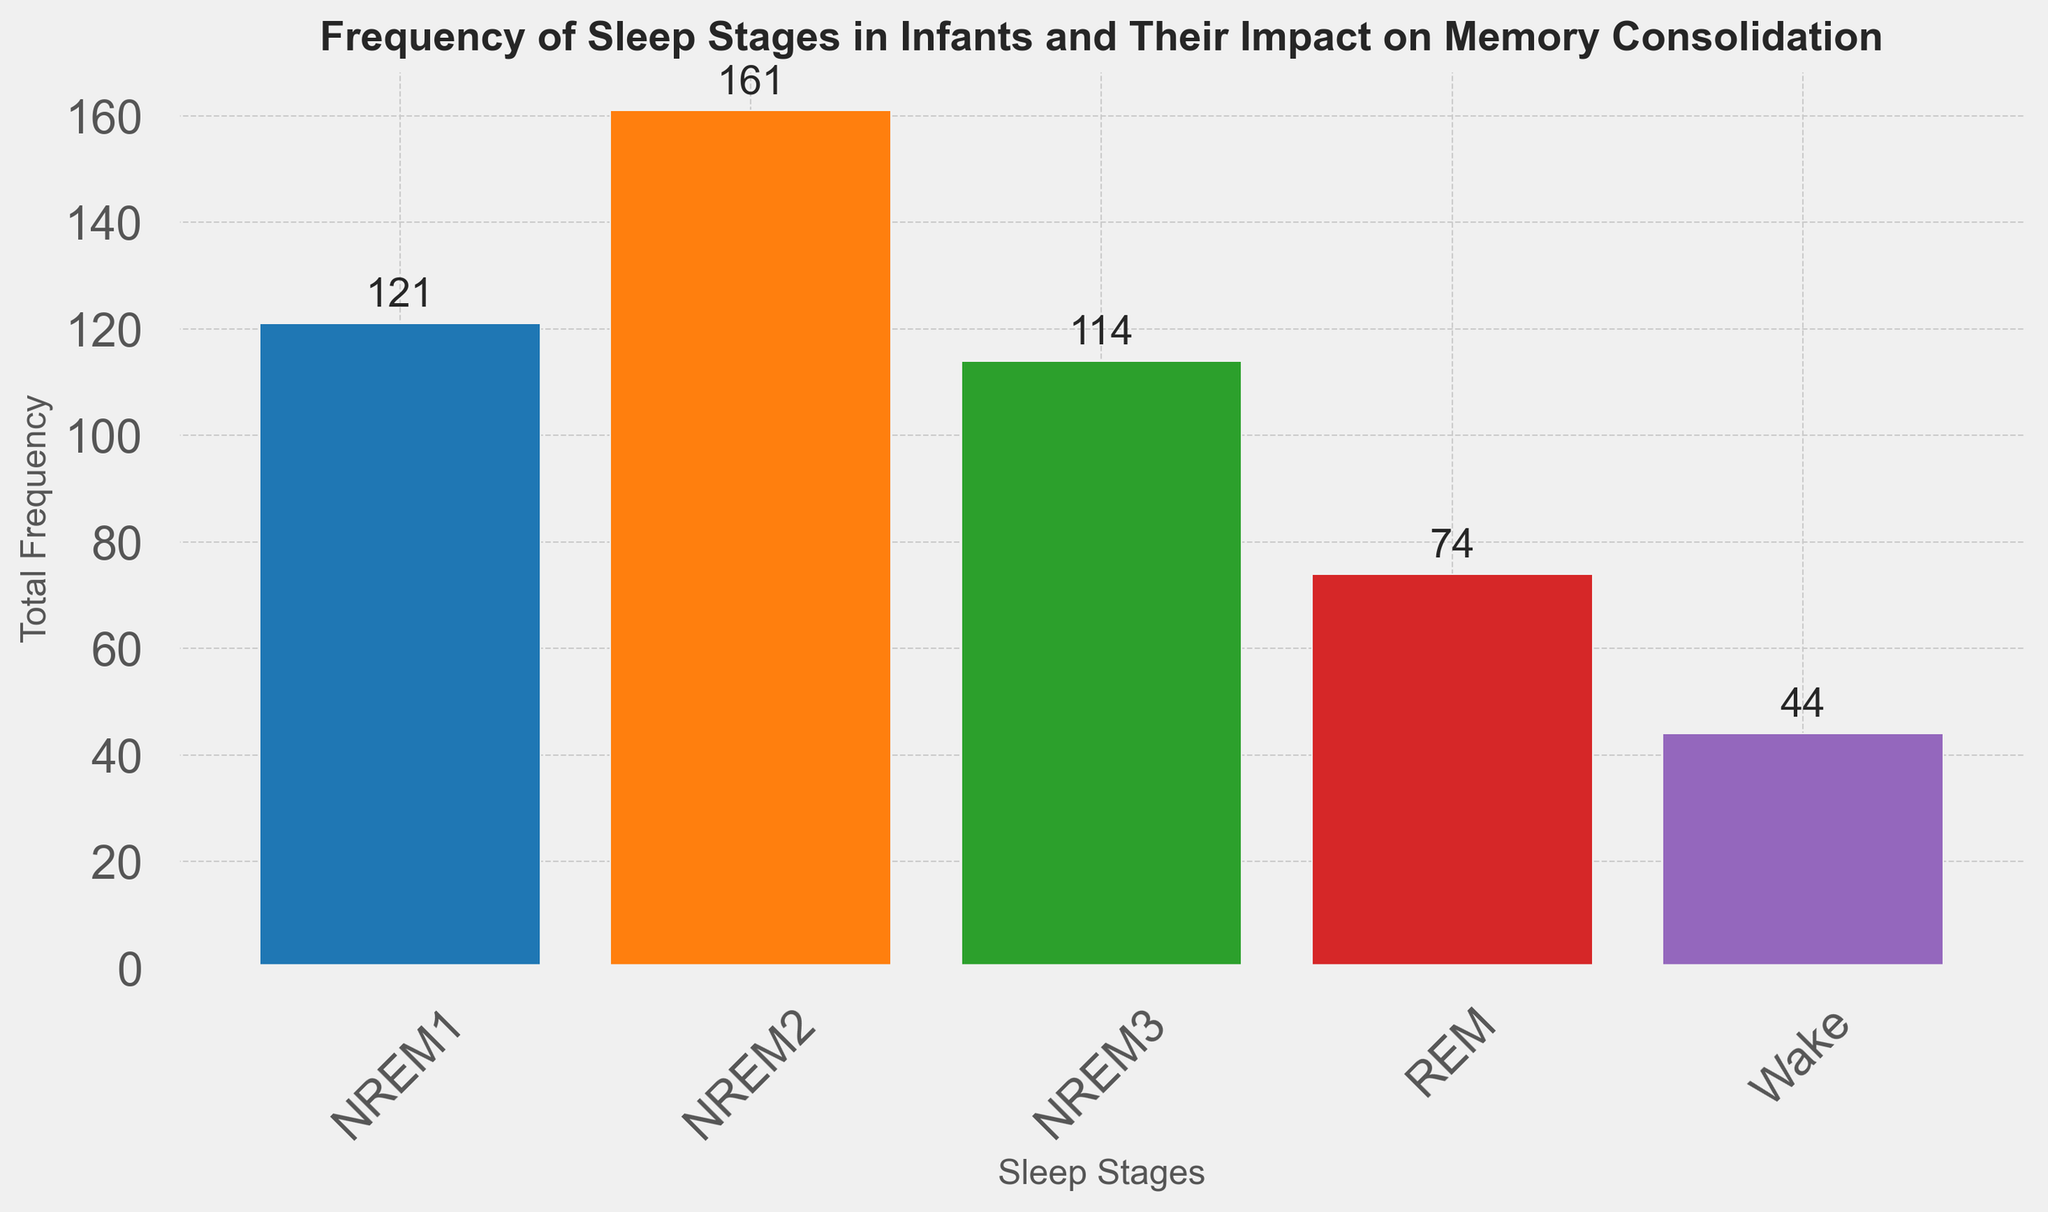What is the total frequency of REM sleep stages observed in the dataset? From the figure, we need to sum the frequencies of REM sleep stages. Identifying the REM bars, the total frequency is obtained from adding the heights of each REM bar: 15 + 12 + 17 + 14 + 16
Answer: 74 Which sleep stage has the highest total frequency? Look at the bar heights in the figure and pinpoint the tallest one. The sleep stage with the highest frequency is represented by the tallest bar. NREM2 sleep has the tallest bar with a total frequency summing up to all NREM2 frequencies: 30 + 35 + 33 + 32 + 31
Answer: NREM2 How does the frequency of Wake stages compare to NREM3 stages? Compare the heights of the Wake and NREM3 bars. For Wake: 10 + 8 + 6 + 9 + 11, and for NREM3: 20 + 22 + 24 + 23 + 25, summing them up gives us Wake: 44 and NREM3: 114. NREM3 is significantly more frequent than Wake stages.
Answer: NREM3 is more frequent than Wake Which sleep stage has the least impact on memory consolidation? Each sleep stage's impact on memory consolidation is mentioned directly. Wake stages are noted as having 'None' impact on memory consolidation. Analyzing throughout the visual, Wake stages have the least impact.
Answer: Wake What is the combined frequency of sleep stages with 'High' impact on memory consolidation? The sleep stages with 'High' impact are REM and NREM2. Sum the frequencies of REM: 15 + 12 + 17 + 14 + 16 and NREM2: 30 + 35 + 33 + 32 + 31. REM: 74, NREM2: 161, combined: 74 + 161
Answer: 235 